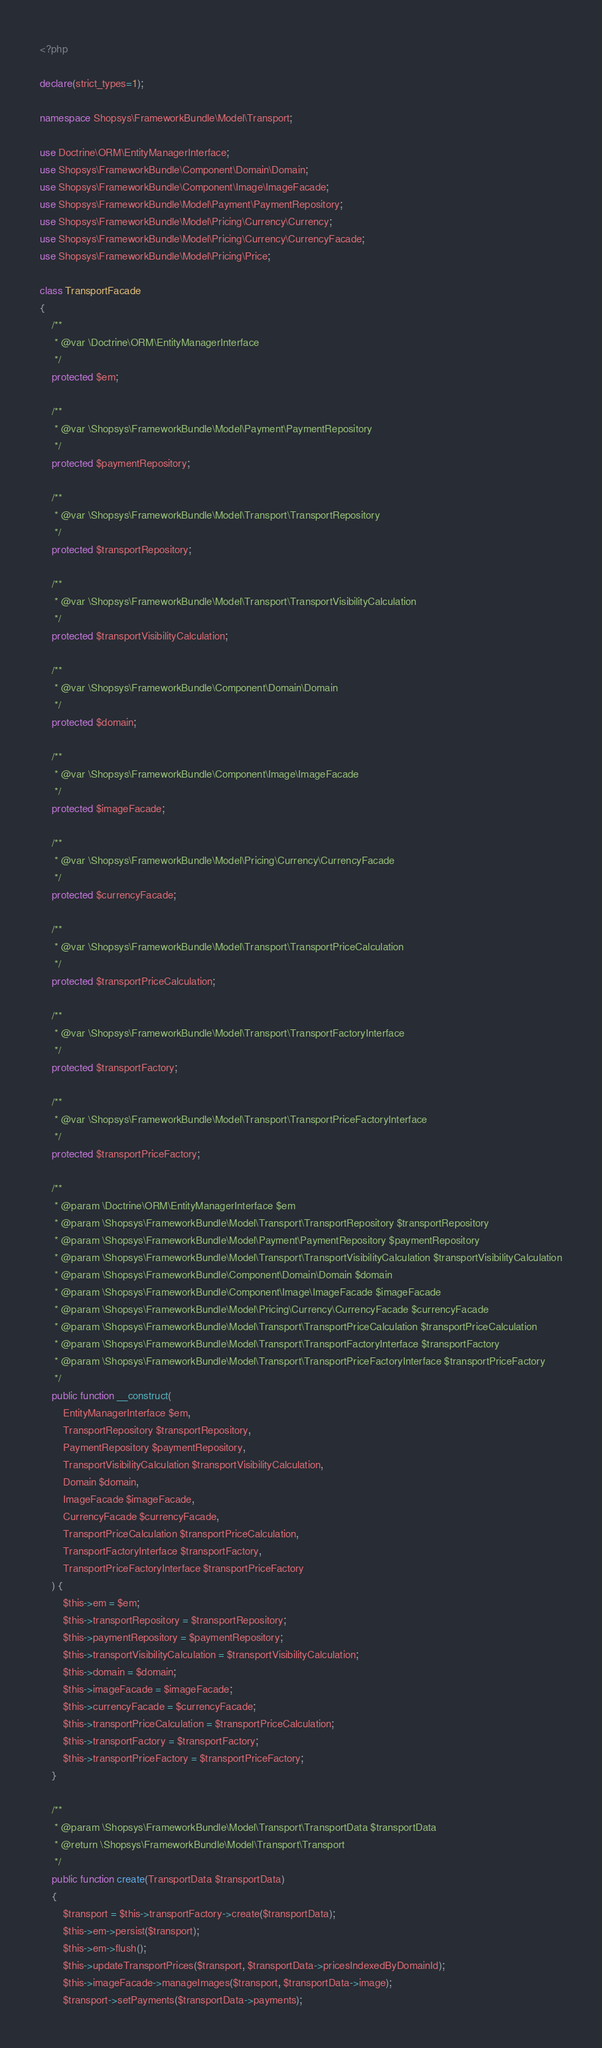Convert code to text. <code><loc_0><loc_0><loc_500><loc_500><_PHP_><?php

declare(strict_types=1);

namespace Shopsys\FrameworkBundle\Model\Transport;

use Doctrine\ORM\EntityManagerInterface;
use Shopsys\FrameworkBundle\Component\Domain\Domain;
use Shopsys\FrameworkBundle\Component\Image\ImageFacade;
use Shopsys\FrameworkBundle\Model\Payment\PaymentRepository;
use Shopsys\FrameworkBundle\Model\Pricing\Currency\Currency;
use Shopsys\FrameworkBundle\Model\Pricing\Currency\CurrencyFacade;
use Shopsys\FrameworkBundle\Model\Pricing\Price;

class TransportFacade
{
    /**
     * @var \Doctrine\ORM\EntityManagerInterface
     */
    protected $em;

    /**
     * @var \Shopsys\FrameworkBundle\Model\Payment\PaymentRepository
     */
    protected $paymentRepository;

    /**
     * @var \Shopsys\FrameworkBundle\Model\Transport\TransportRepository
     */
    protected $transportRepository;

    /**
     * @var \Shopsys\FrameworkBundle\Model\Transport\TransportVisibilityCalculation
     */
    protected $transportVisibilityCalculation;

    /**
     * @var \Shopsys\FrameworkBundle\Component\Domain\Domain
     */
    protected $domain;

    /**
     * @var \Shopsys\FrameworkBundle\Component\Image\ImageFacade
     */
    protected $imageFacade;

    /**
     * @var \Shopsys\FrameworkBundle\Model\Pricing\Currency\CurrencyFacade
     */
    protected $currencyFacade;

    /**
     * @var \Shopsys\FrameworkBundle\Model\Transport\TransportPriceCalculation
     */
    protected $transportPriceCalculation;

    /**
     * @var \Shopsys\FrameworkBundle\Model\Transport\TransportFactoryInterface
     */
    protected $transportFactory;

    /**
     * @var \Shopsys\FrameworkBundle\Model\Transport\TransportPriceFactoryInterface
     */
    protected $transportPriceFactory;

    /**
     * @param \Doctrine\ORM\EntityManagerInterface $em
     * @param \Shopsys\FrameworkBundle\Model\Transport\TransportRepository $transportRepository
     * @param \Shopsys\FrameworkBundle\Model\Payment\PaymentRepository $paymentRepository
     * @param \Shopsys\FrameworkBundle\Model\Transport\TransportVisibilityCalculation $transportVisibilityCalculation
     * @param \Shopsys\FrameworkBundle\Component\Domain\Domain $domain
     * @param \Shopsys\FrameworkBundle\Component\Image\ImageFacade $imageFacade
     * @param \Shopsys\FrameworkBundle\Model\Pricing\Currency\CurrencyFacade $currencyFacade
     * @param \Shopsys\FrameworkBundle\Model\Transport\TransportPriceCalculation $transportPriceCalculation
     * @param \Shopsys\FrameworkBundle\Model\Transport\TransportFactoryInterface $transportFactory
     * @param \Shopsys\FrameworkBundle\Model\Transport\TransportPriceFactoryInterface $transportPriceFactory
     */
    public function __construct(
        EntityManagerInterface $em,
        TransportRepository $transportRepository,
        PaymentRepository $paymentRepository,
        TransportVisibilityCalculation $transportVisibilityCalculation,
        Domain $domain,
        ImageFacade $imageFacade,
        CurrencyFacade $currencyFacade,
        TransportPriceCalculation $transportPriceCalculation,
        TransportFactoryInterface $transportFactory,
        TransportPriceFactoryInterface $transportPriceFactory
    ) {
        $this->em = $em;
        $this->transportRepository = $transportRepository;
        $this->paymentRepository = $paymentRepository;
        $this->transportVisibilityCalculation = $transportVisibilityCalculation;
        $this->domain = $domain;
        $this->imageFacade = $imageFacade;
        $this->currencyFacade = $currencyFacade;
        $this->transportPriceCalculation = $transportPriceCalculation;
        $this->transportFactory = $transportFactory;
        $this->transportPriceFactory = $transportPriceFactory;
    }

    /**
     * @param \Shopsys\FrameworkBundle\Model\Transport\TransportData $transportData
     * @return \Shopsys\FrameworkBundle\Model\Transport\Transport
     */
    public function create(TransportData $transportData)
    {
        $transport = $this->transportFactory->create($transportData);
        $this->em->persist($transport);
        $this->em->flush();
        $this->updateTransportPrices($transport, $transportData->pricesIndexedByDomainId);
        $this->imageFacade->manageImages($transport, $transportData->image);
        $transport->setPayments($transportData->payments);</code> 